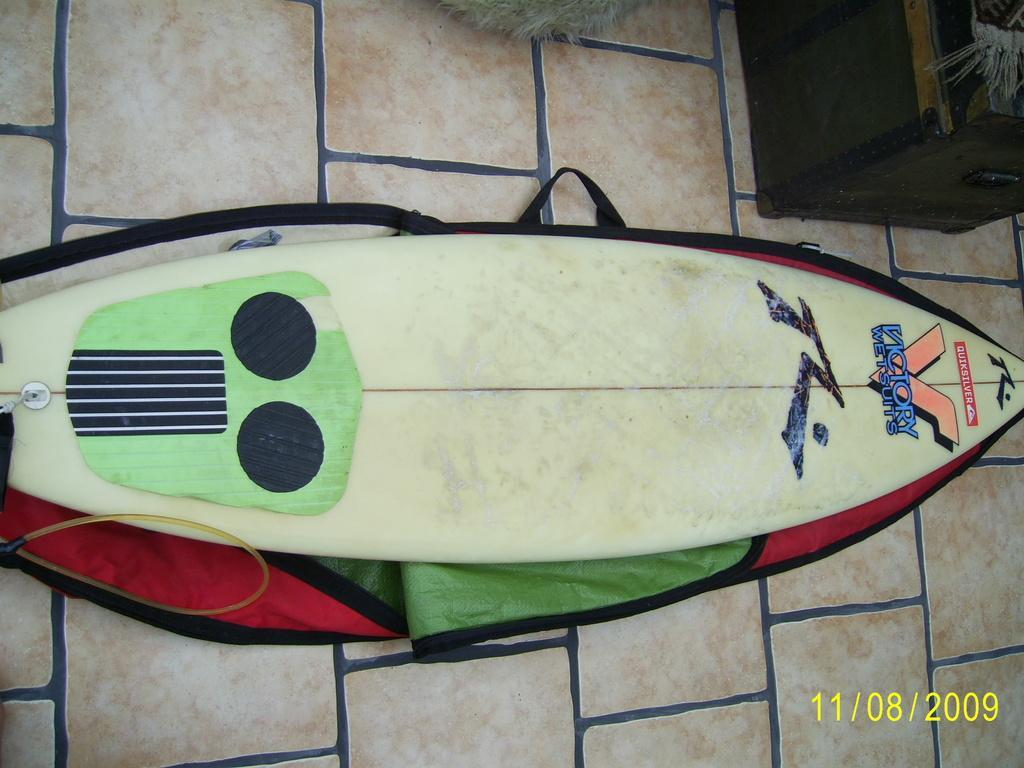Describe this image in one or two sentences. In this image I can see a surfboard on the floor. There is a box at the top and date is mentioned at the bottom. 